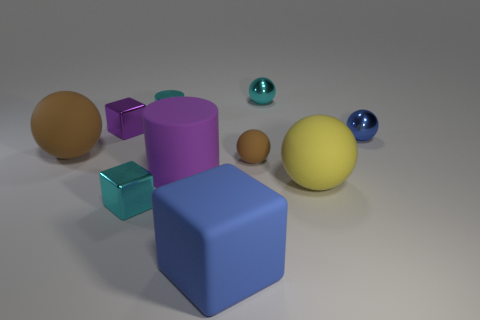What number of other things are the same material as the big blue block?
Provide a succinct answer. 4. There is a yellow matte thing that is the same shape as the blue metallic object; what is its size?
Ensure brevity in your answer.  Large. There is a big thing that is behind the tiny sphere to the left of the metal ball left of the yellow ball; what is its material?
Ensure brevity in your answer.  Rubber. Is there a tiny blue metal thing?
Ensure brevity in your answer.  Yes. There is a big matte cube; is it the same color as the metallic ball that is behind the blue metal thing?
Your answer should be compact. No. What color is the tiny rubber object?
Give a very brief answer. Brown. Are there any other things that are the same shape as the big blue rubber thing?
Ensure brevity in your answer.  Yes. There is another large thing that is the same shape as the yellow thing; what is its color?
Your answer should be very brief. Brown. Does the small brown object have the same shape as the purple matte thing?
Provide a short and direct response. No. What number of blocks are large blue objects or big purple things?
Your response must be concise. 1. 